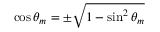<formula> <loc_0><loc_0><loc_500><loc_500>\cos \theta _ { m } = \pm \sqrt { 1 - \sin ^ { 2 } \theta _ { m } }</formula> 